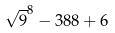<formula> <loc_0><loc_0><loc_500><loc_500>\sqrt { 9 } ^ { 8 } - 3 8 8 + 6</formula> 